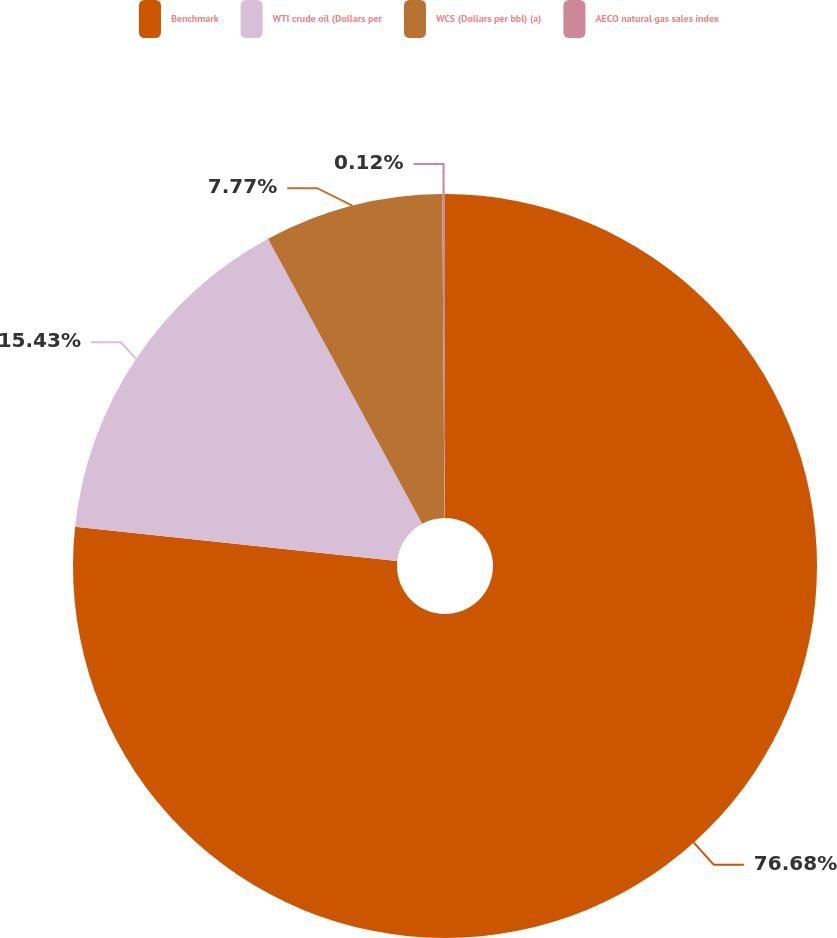Convert chart to OTSL. <chart><loc_0><loc_0><loc_500><loc_500><pie_chart><fcel>Benchmark<fcel>WTI crude oil (Dollars per<fcel>WCS (Dollars per bbl) (a)<fcel>AECO natural gas sales index<nl><fcel>76.68%<fcel>15.43%<fcel>7.77%<fcel>0.12%<nl></chart> 